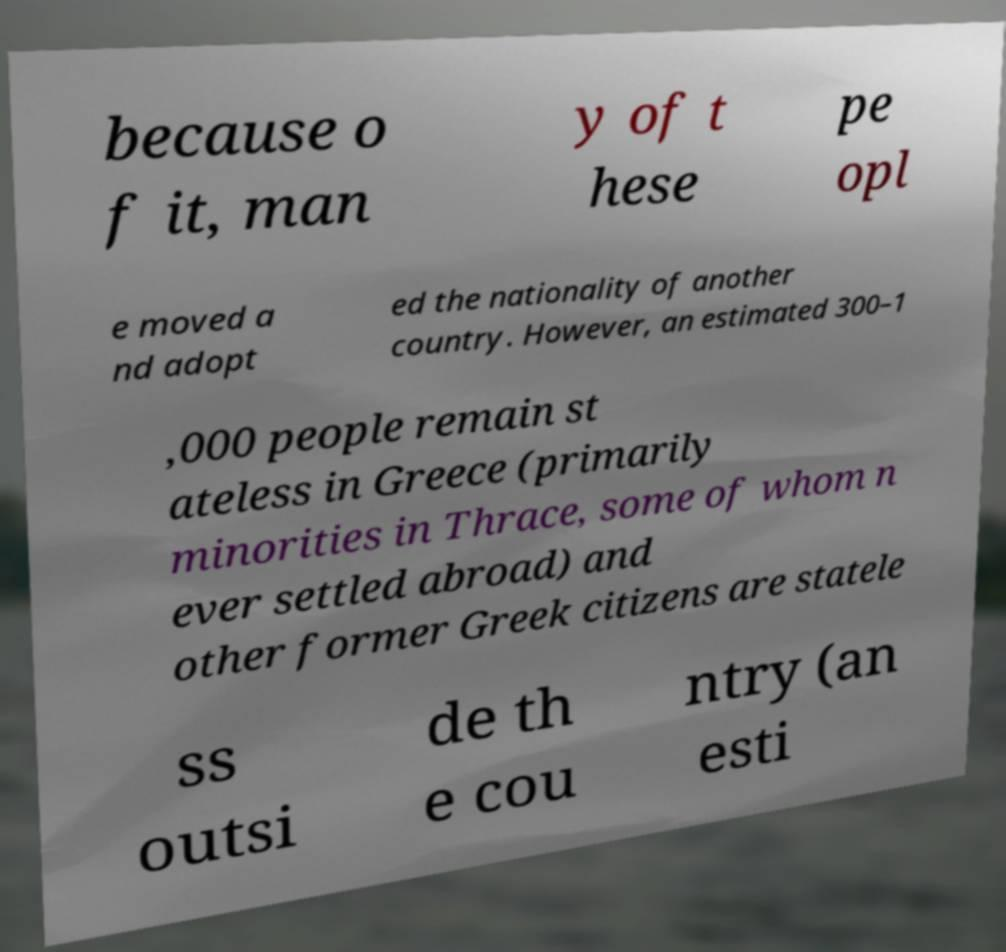What messages or text are displayed in this image? I need them in a readable, typed format. because o f it, man y of t hese pe opl e moved a nd adopt ed the nationality of another country. However, an estimated 300–1 ,000 people remain st ateless in Greece (primarily minorities in Thrace, some of whom n ever settled abroad) and other former Greek citizens are statele ss outsi de th e cou ntry (an esti 